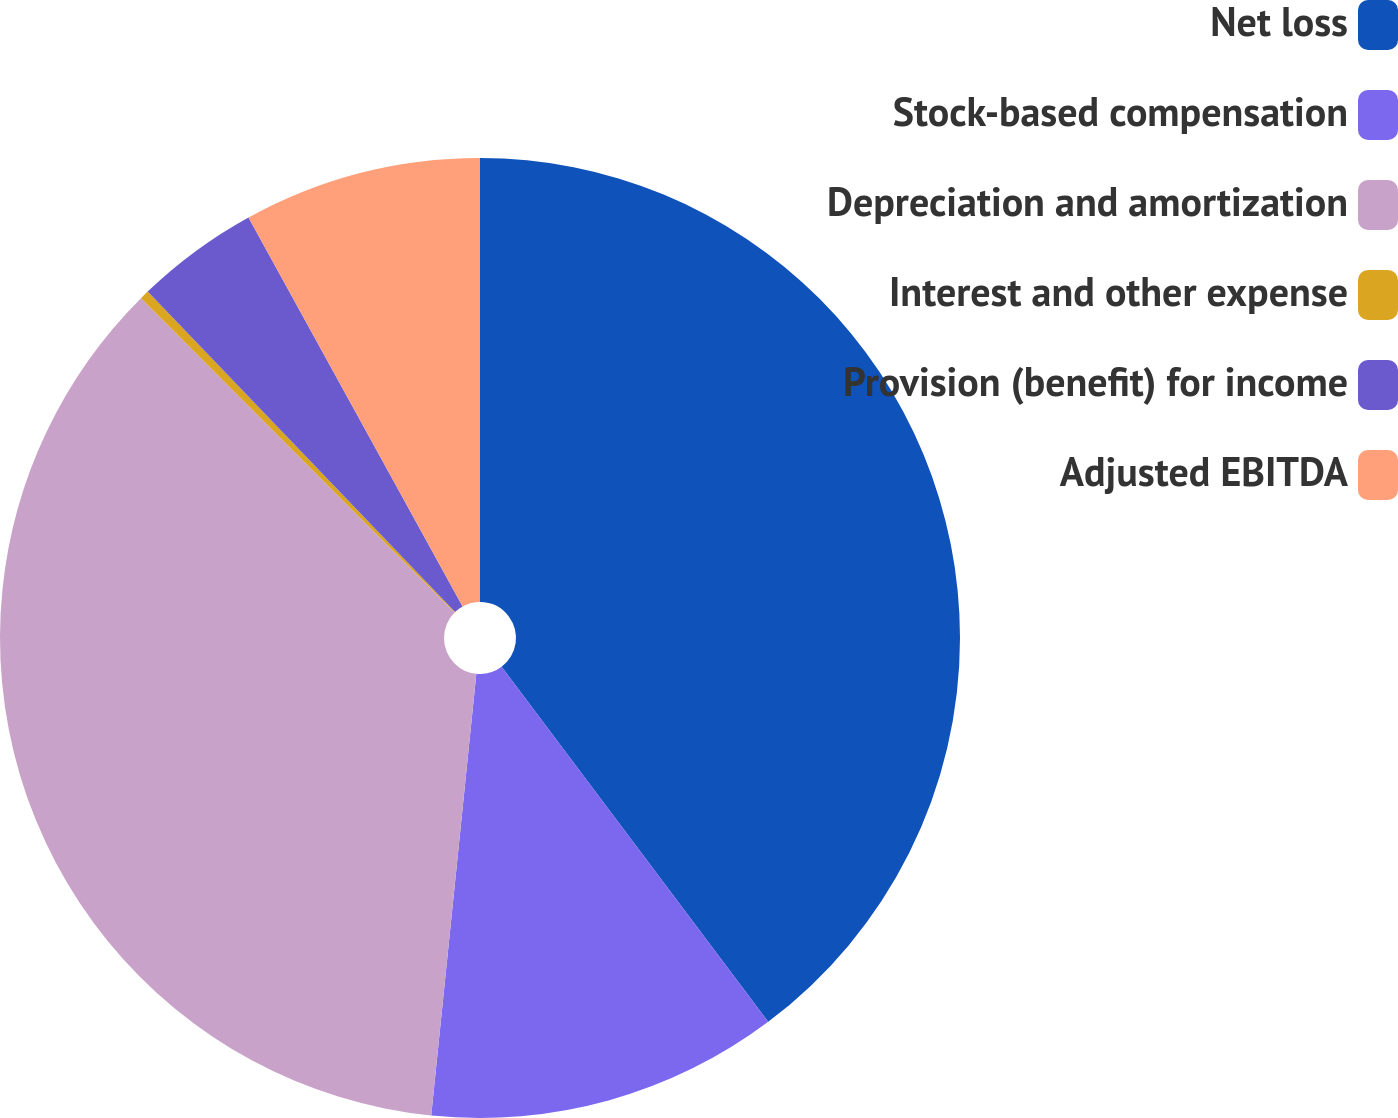<chart> <loc_0><loc_0><loc_500><loc_500><pie_chart><fcel>Net loss<fcel>Stock-based compensation<fcel>Depreciation and amortization<fcel>Interest and other expense<fcel>Provision (benefit) for income<fcel>Adjusted EBITDA<nl><fcel>39.75%<fcel>11.87%<fcel>35.9%<fcel>0.31%<fcel>4.16%<fcel>8.01%<nl></chart> 